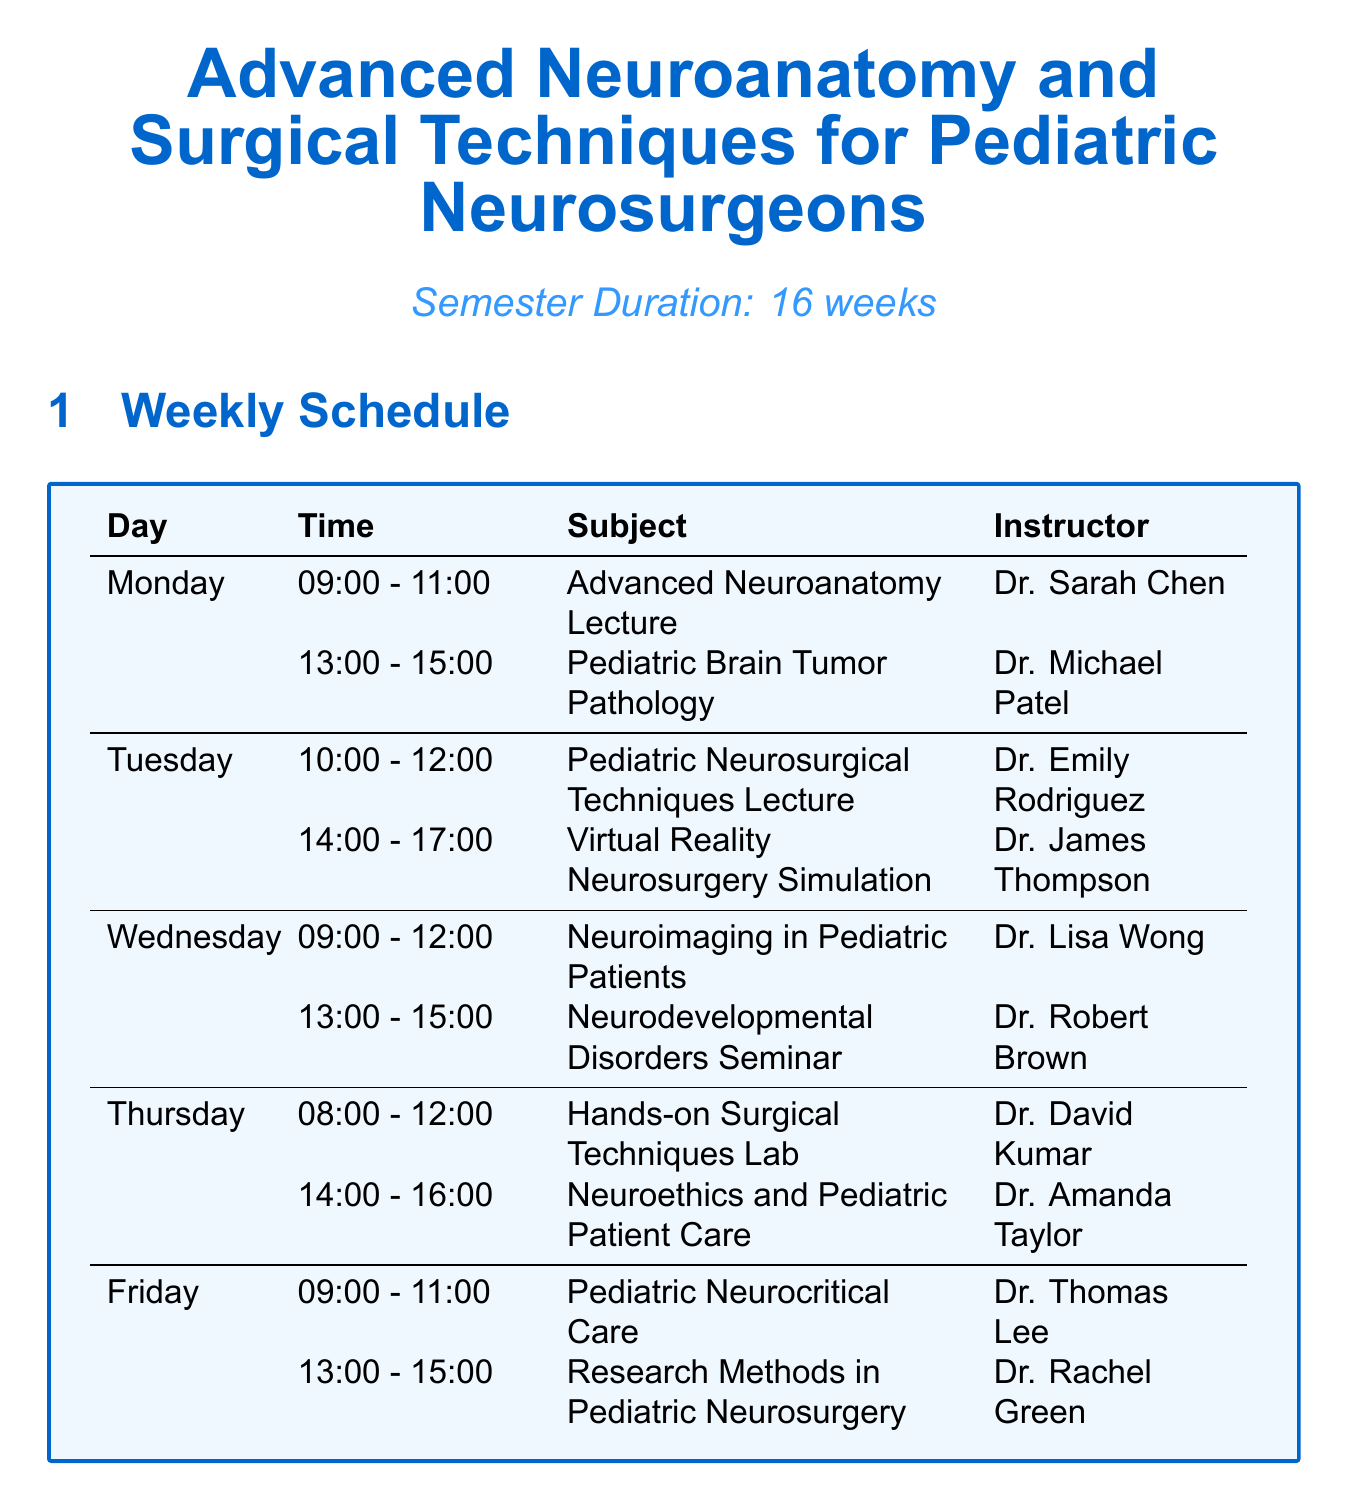What is the duration of the semester? The semester duration is explicitly stated in the document as 16 weeks.
Answer: 16 weeks Who teaches the Advanced Neuroanatomy Lecture? The document lists the instructor for the Advanced Neuroanatomy Lecture as Dr. Sarah Chen.
Answer: Dr. Sarah Chen What day and time is the Hands-on Surgical Techniques Lab scheduled? This lab session is on Thursday from 8:00 to 12:00 according to the weekly schedule.
Answer: Thursday, 8:00 - 12:00 What practical exam occurs in week 16? The document specifically identifies the Final Practical Exam as occurring in week 16.
Answer: Final Practical Exam How often are the Operating Room Observations scheduled? It is stated in the document that the frequency of Operating Room Observation is bi-weekly.
Answer: Bi-weekly Which room is used for the Neurodevelopmental Disorders Seminar? The location for the Neurodevelopmental Disorders Seminar is given as the Pediatric Neurology Conference Room.
Answer: Pediatric Neurology Conference Room What is the maximum duration for the Journal Club? The document specifies that the Journal Club lasts for 2 hours.
Answer: 2 hours What components are included in the Midterm Practical Exam? The document lists the components as Neuroanatomy identification, Basic surgical techniques demonstration, and Case-based problem-solving.
Answer: Neuroanatomy identification, Basic surgical techniques demonstration, Case-based problem-solving 